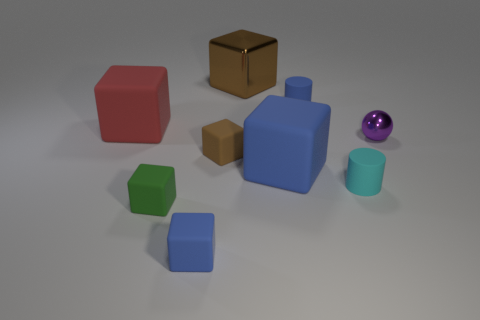How many other objects are the same color as the shiny block?
Make the answer very short. 1. There is a shiny block; is it the same color as the small block that is on the right side of the tiny blue cube?
Your answer should be very brief. Yes. There is a brown cube that is the same size as the red matte cube; what is its material?
Your response must be concise. Metal. How many tiny things are either red rubber cubes or brown metal things?
Ensure brevity in your answer.  0. Are there fewer brown metal blocks than large blocks?
Your answer should be compact. Yes. What is the color of the large metal thing that is the same shape as the brown rubber object?
Provide a succinct answer. Brown. Is there anything else that has the same shape as the purple object?
Provide a short and direct response. No. Are there more tiny green rubber things than big rubber objects?
Offer a very short reply. No. What number of other things are there of the same material as the purple sphere
Keep it short and to the point. 1. What is the shape of the brown object behind the metallic object in front of the small blue thing that is behind the tiny purple object?
Make the answer very short. Cube. 